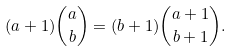<formula> <loc_0><loc_0><loc_500><loc_500>( a + 1 ) \binom { a } { b } = ( b + 1 ) \binom { a + 1 } { b + 1 } .</formula> 